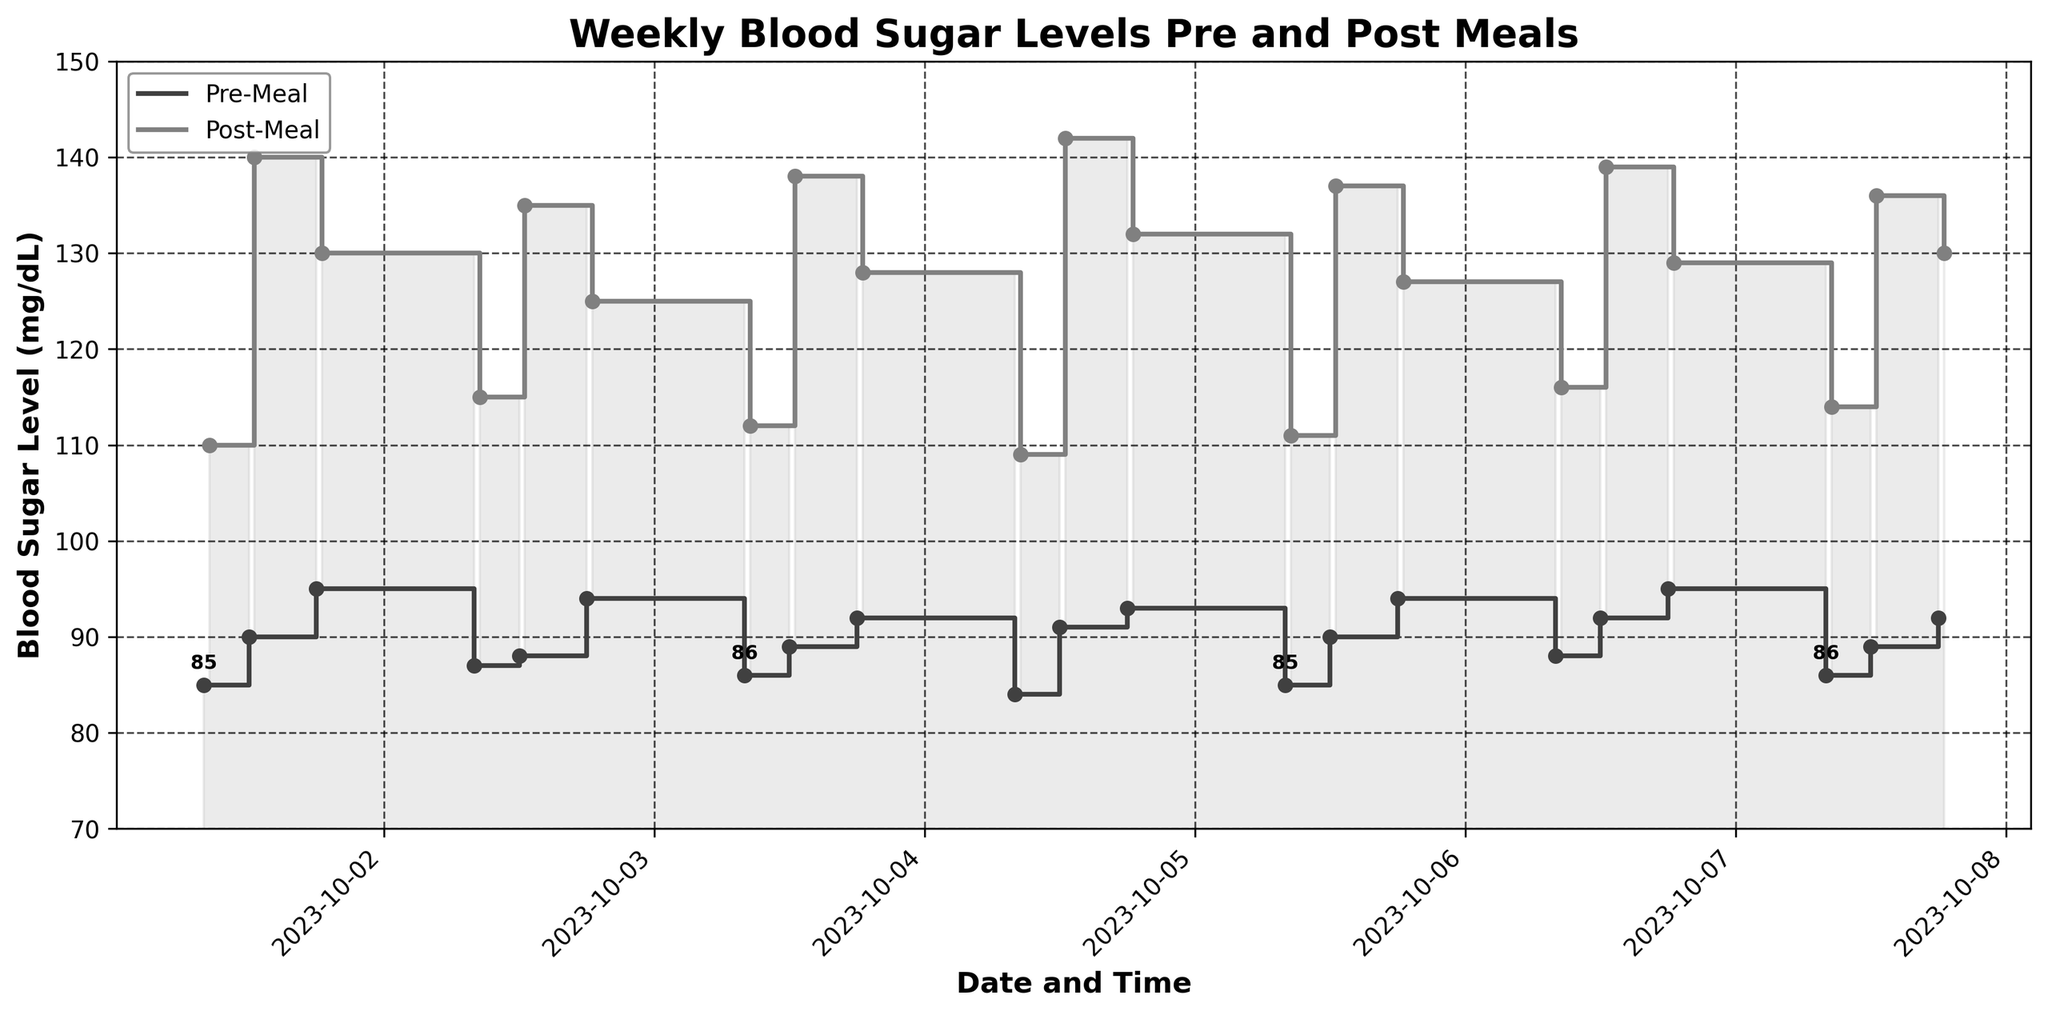What's the title of the chart? The title is located at the top of the figure. It serves to inform the viewer about the content of the plot.
Answer: Weekly Blood Sugar Levels Pre and Post Meals What range is set for the y-axis in the chart? The y-axis range can be found on the left side of the figure, showing minimum and maximum values for blood sugar levels.
Answer: 70 to 150 How are the pre-meal and post-meal blood sugar levels represented differently? The different representations are identifiable by color and line style in the chart's legend.
Answer: Pre-meal levels are shown in darker lines, post-meal levels in lighter lines What date and time had the highest post-meal blood sugar level? To find the highest post-meal blood sugar level, locate the highest point in the lighter line and then cross-check with the x-axis for the corresponding date and time.
Answer: 2023-10-04 12:30 On October 3, 2023, what’s the difference in blood sugar levels between pre-meal at 18:00 and post-meal at 18:30? The difference is calculated by subtracting the pre-meal level from the post-meal level for the given date and times.
Answer: 36 Which day had the most significant increase in post-meal blood sugar levels at 12:30 compared to pre-meal levels at 12:00? Compare the difference between post-meal and pre-meal levels on each day at the specified times to determine the largest increase.
Answer: October 4, 2023 What overall trend can be observed in the pre-meal blood sugar levels from October 1 to October 7? Observe the general direction of the darker line representing pre-meal levels over the week to identify any trends.
Answer: It fluctuated slightly within a narrow range Are there more instances where the blood sugar level post-meal is above 120 mg/dL or below it? Count the instances in the lighter line where values are above 120 and compare them to those below 120.
Answer: More instances above 120 mg/dL Which specific time of the day consistently shows the highest post-meal blood sugar levels? Compare the three distinct post-meal times (08:30, 12:30, and 18:30) across the week to identify which has the highest levels most consistently.
Answer: 12:30 